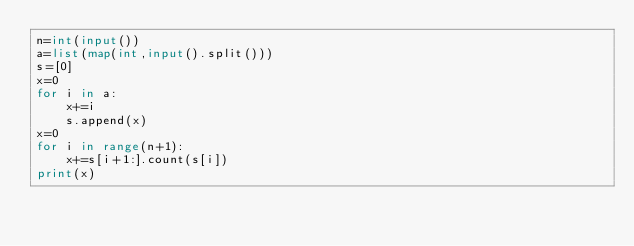<code> <loc_0><loc_0><loc_500><loc_500><_Python_>n=int(input())
a=list(map(int,input().split()))
s=[0]
x=0
for i in a:
    x+=i
    s.append(x)
x=0
for i in range(n+1):
    x+=s[i+1:].count(s[i])
print(x)</code> 